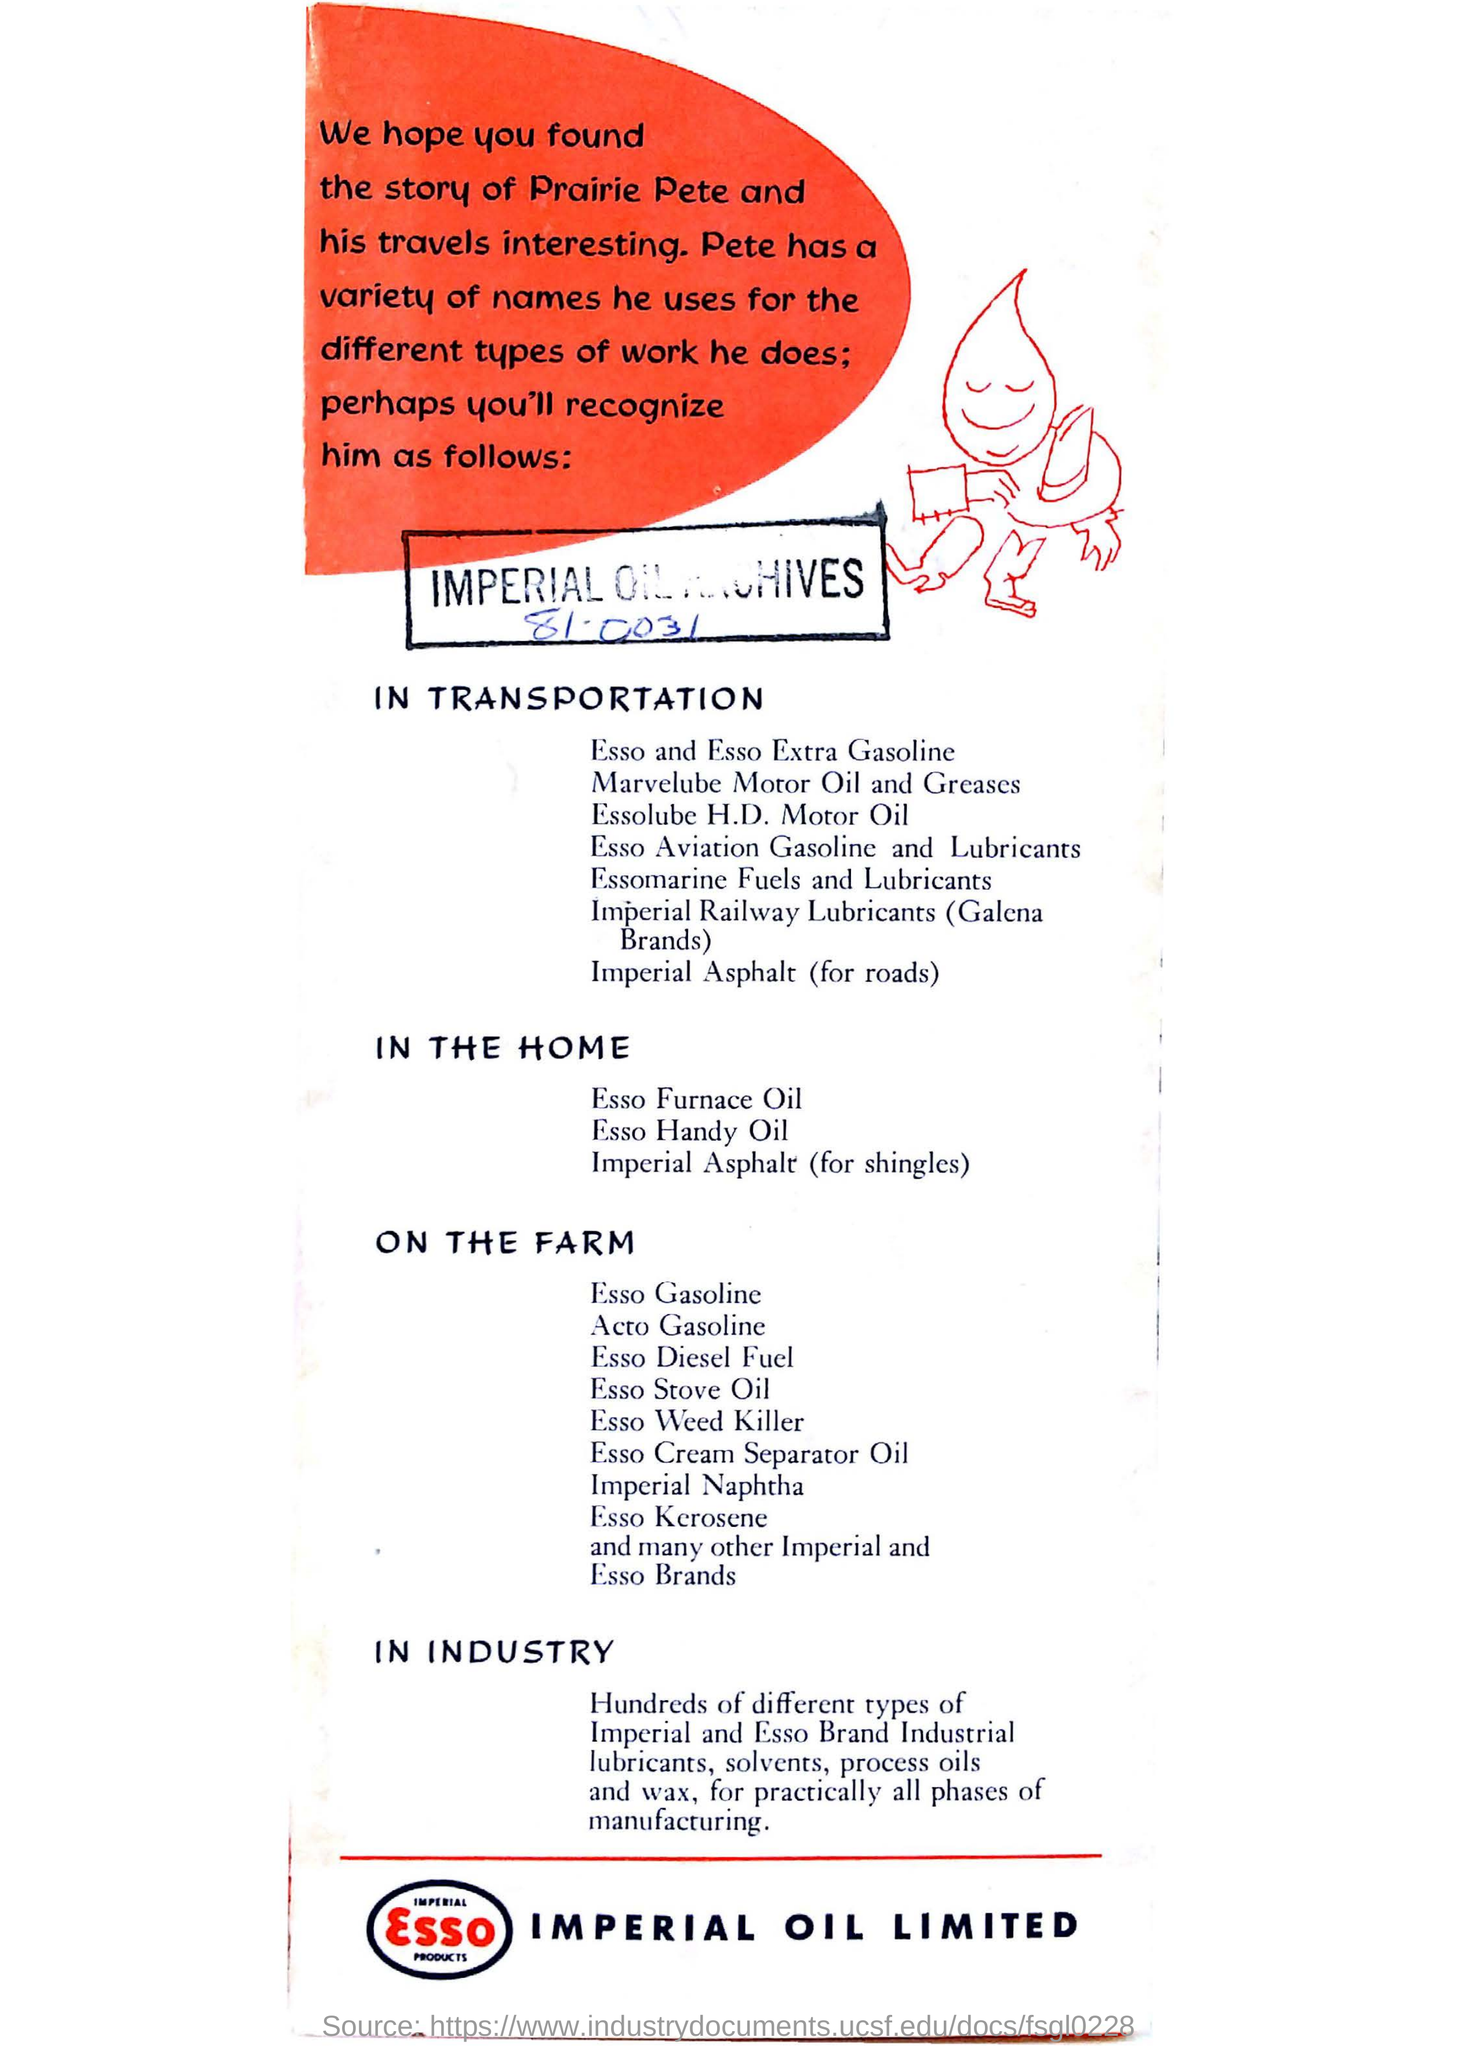Whose advertisement is this ?
Your answer should be compact. ESSO IMPERIAL OIL LIMITED. 